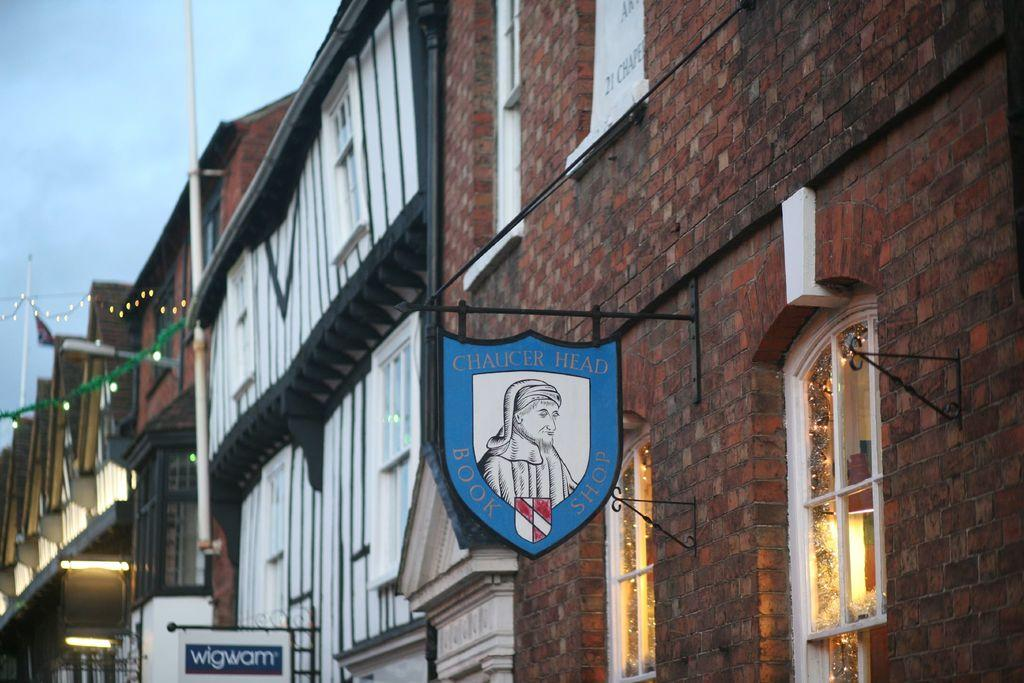What type of structures are present in the image? There are buildings in the image. What can be seen on the walls of the buildings? There are boards with text on the walls of the buildings. How would you describe the sky in the image? The sky is cloudy in the image. Can you tell me how many friends are visible in the image? There is no mention of friends in the image, as it primarily features buildings and text on their walls. What type of transport is being used by the plough in the image? There is no plough or transport present in the image; it focuses on buildings and their walls. 